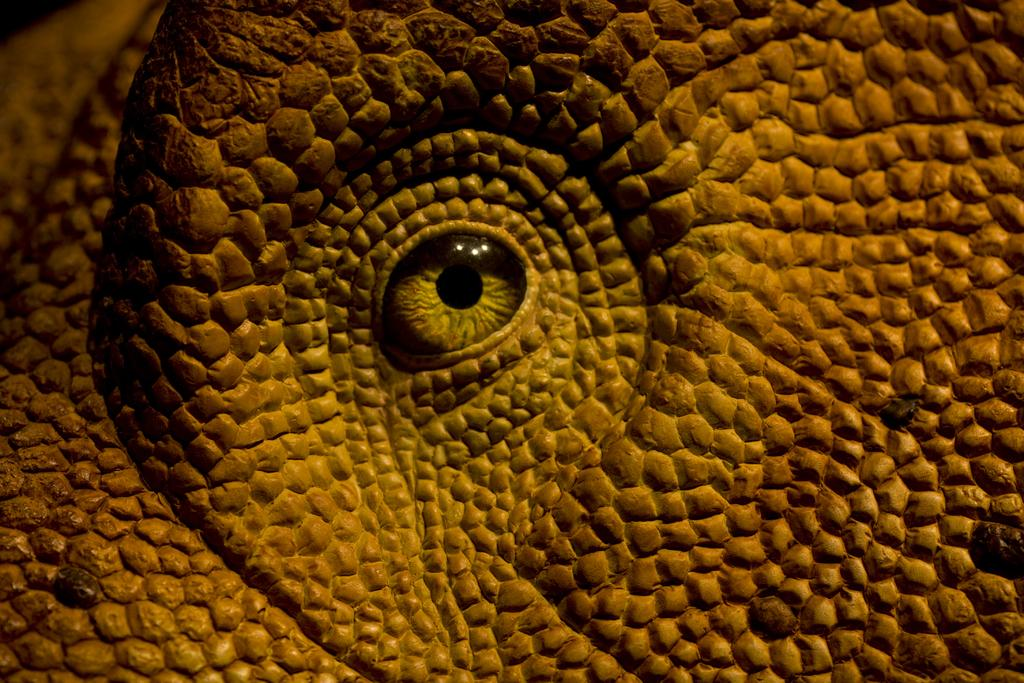What is the main subject of the image? The main subject of the image is the eye of an animal. Can you describe the eye in the image? The eye appears to be that of an animal, but no specific details about the eye or the animal can be determined from the image alone. What type of government is being discussed in the image? There is no discussion of government in the image, as it only features the eye of an animal. What is the mindset of the animal in the image? There is no way to determine the mindset of the animal in the image, as it only features the eye of the animal and does not provide any information about the animal's thoughts or emotions. 